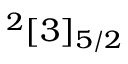Convert formula to latex. <formula><loc_0><loc_0><loc_500><loc_500>^ { 2 } [ 3 ] _ { 5 / 2 }</formula> 